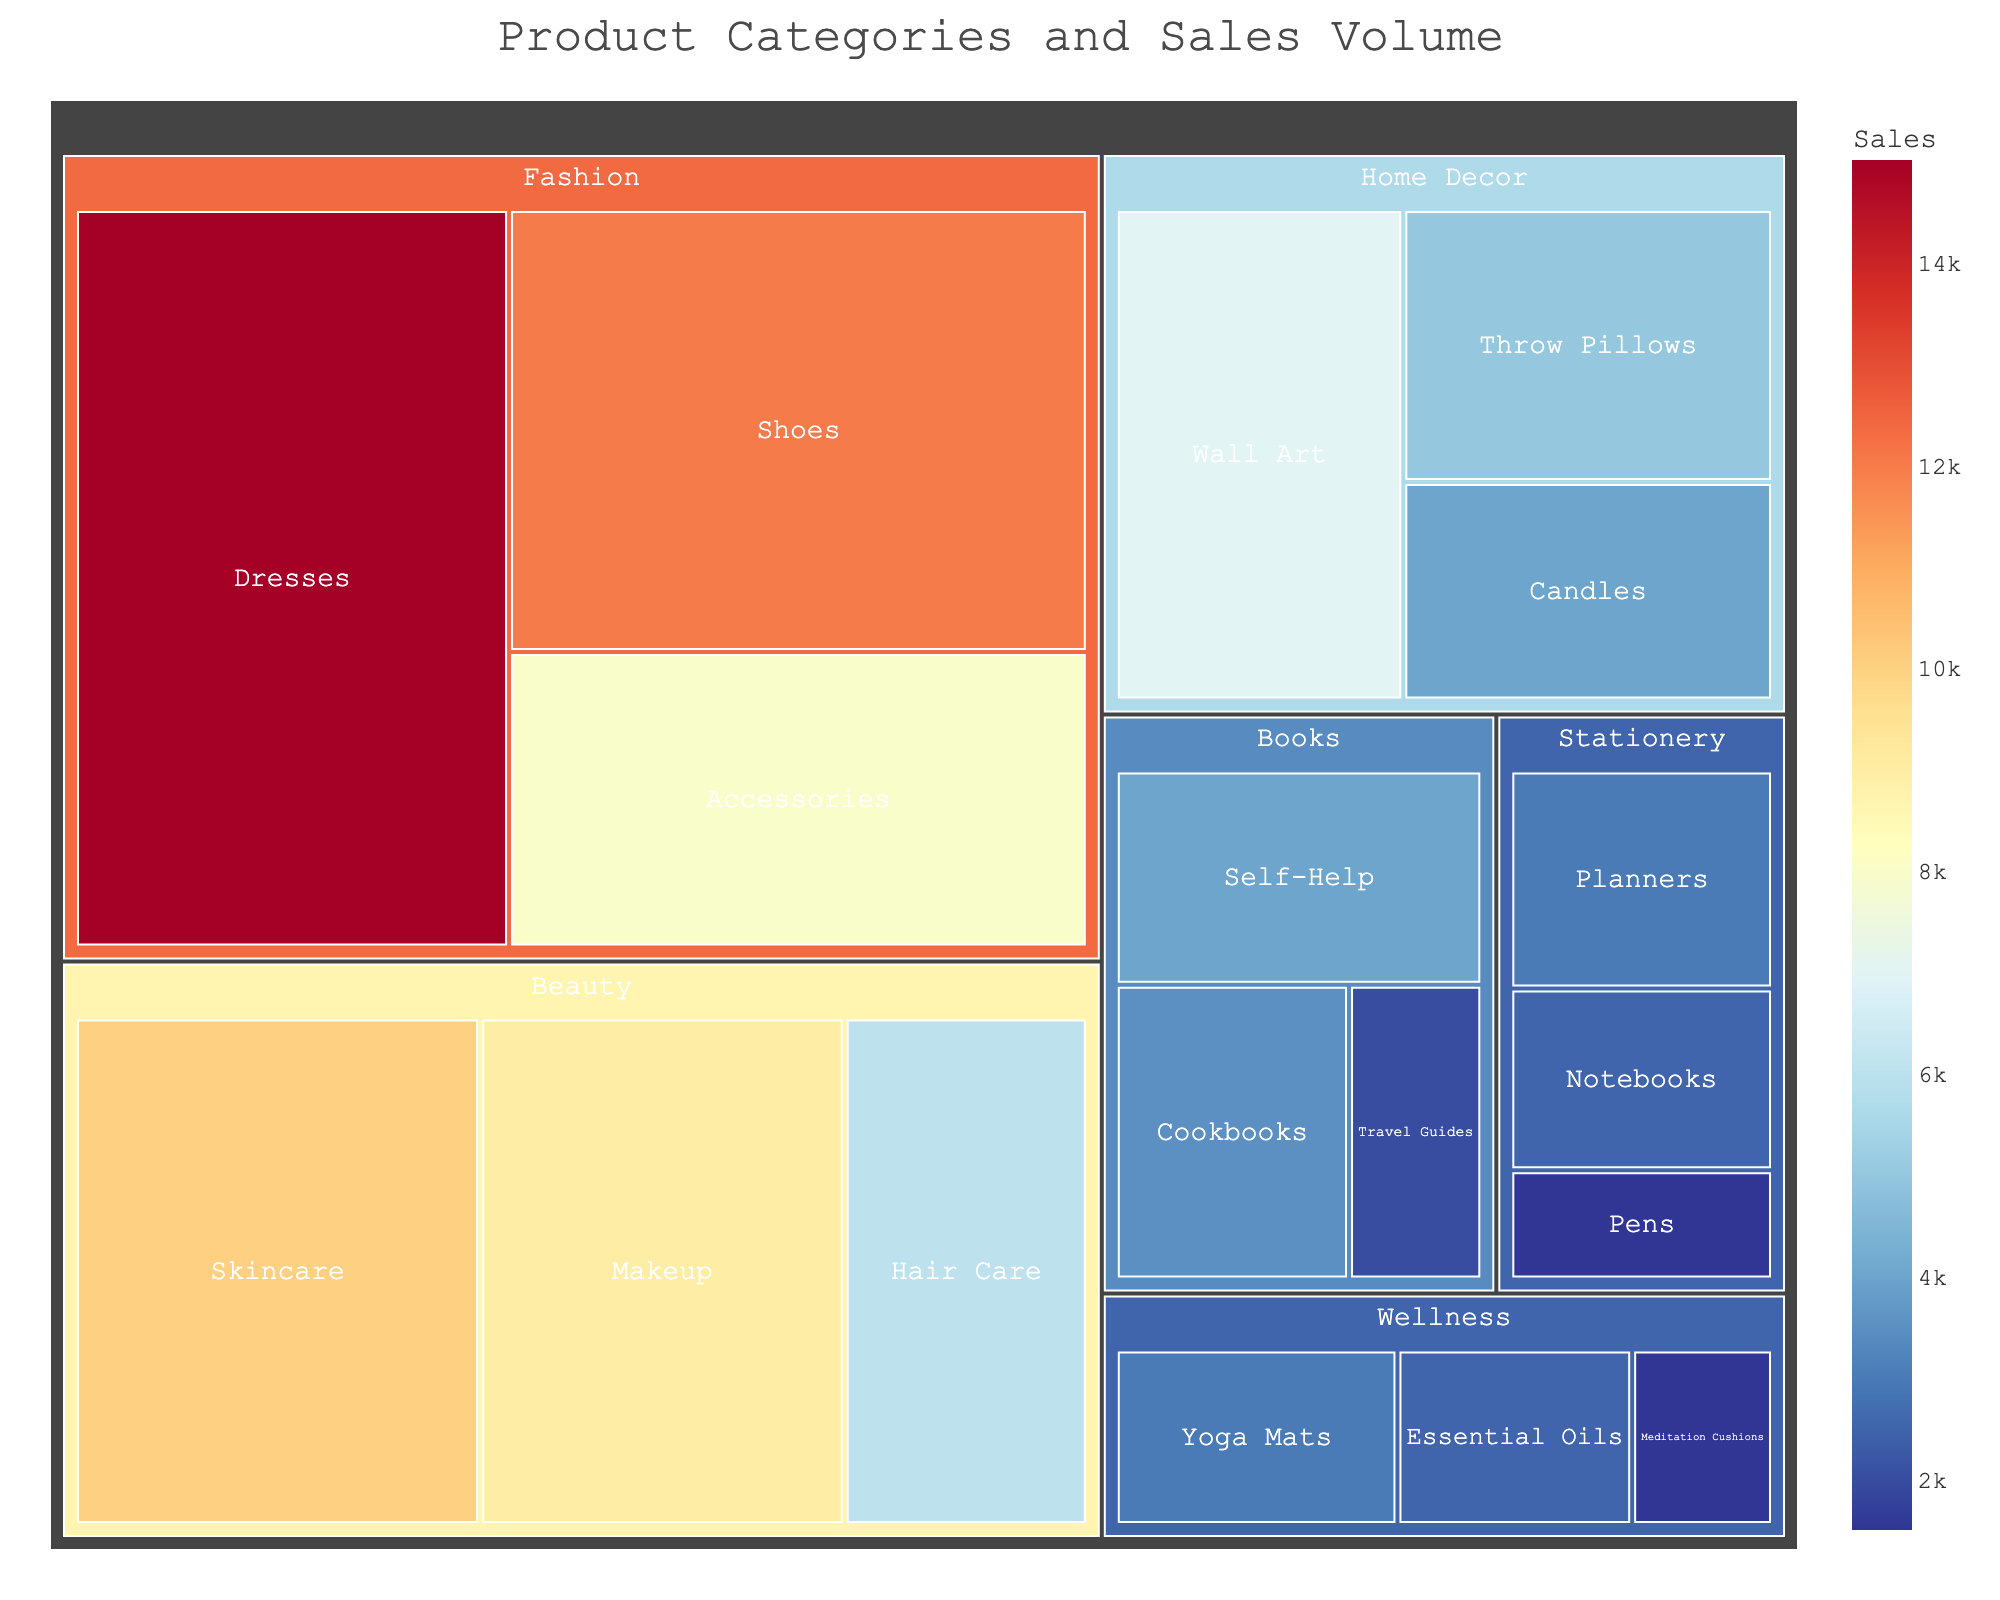What is the title of the treemap? The title is at the top of the treemap and is often used to describe the main content or purpose of the chart.
Answer: Product Categories and Sales Volume Which category has the highest sales volume? Look for the largest segment in the treemap. The size of each segment is proportional to the sales volume.
Answer: Fashion What are the sales volumes for Dresses and Shoes subcategories combined? Locate the Dresses and Shoes subcategories within the Fashion category and sum their sales volumes: 15000 (Dresses) + 12000 (Shoes).
Answer: 27000 Which subcategory in the Wellness category has the lowest sales volume? Within the Wellness category, identify the smallest segment, which represents the lowest sales volume.
Answer: Meditation Cushions Compare the sales volume of Skincare with Makeup. Which one is higher? Locate the Skincare and Makeup subcategories within the Beauty category and compare their sales volumes: 10000 (Skincare) vs 9000 (Makeup).
Answer: Skincare Which category has the smallest total sales volume? Add the sales volumes of all subcategories within each category and compare to identify the smallest sum.
Answer: Stationery What is the average sales volume for the subcategories within the Home Decor category? Sum the sales volumes of all subcategories under Home Decor and divide by the number of subcategories: (7000 + 5000 + 4000)/3.
Answer: 5333.33 How many subcategories are there in total? Count all the subcategories listed under each main category in the treemap.
Answer: 18 Is the sales volume of Throw Pillows higher than that of Wall Art? Compare the sales volumes of the Throw Pillows and Wall Art subcategories within the Home Decor category: 5000 (Throw Pillows) vs 7000 (Wall Art).
Answer: No Identify the color pattern used in the treemap to indicate sales volume. Observe the color gradient in the treemap, which usually represents the range of sales volumes, often from cooler to warmer colors.
Answer: RdYlBu_r (red, yellow, blue reversed) 